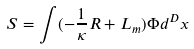<formula> <loc_0><loc_0><loc_500><loc_500>S = \int ( - \frac { 1 } { \kappa } R + L _ { m } ) \Phi d ^ { D } x</formula> 